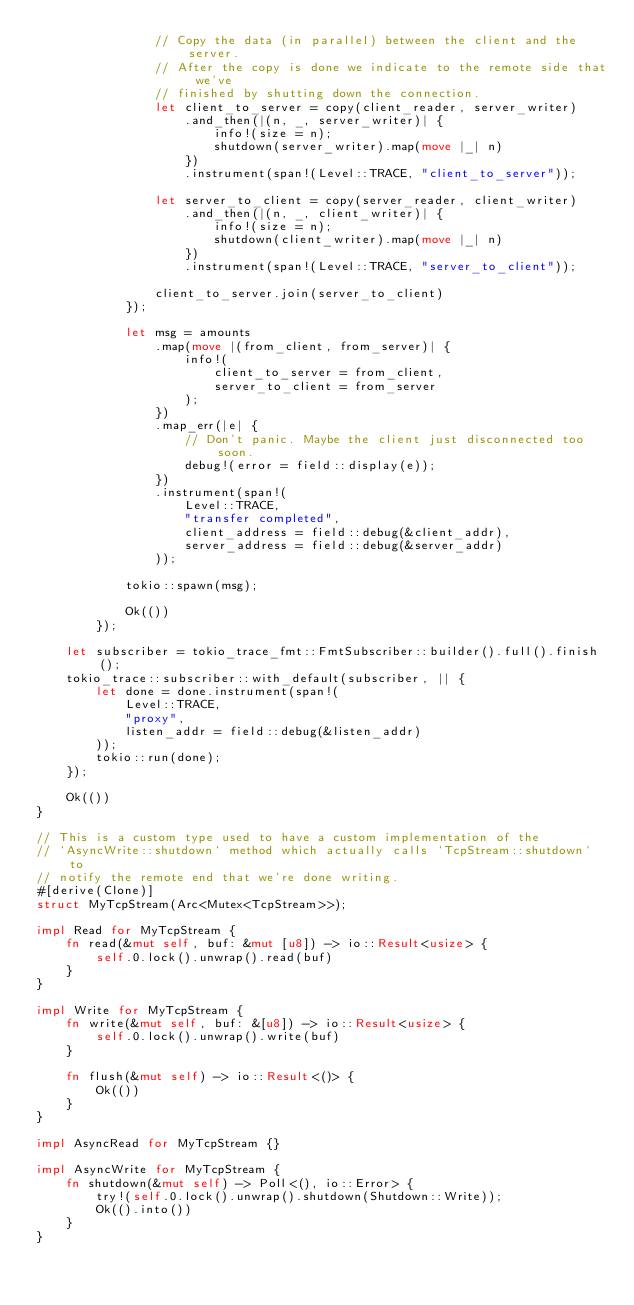Convert code to text. <code><loc_0><loc_0><loc_500><loc_500><_Rust_>                // Copy the data (in parallel) between the client and the server.
                // After the copy is done we indicate to the remote side that we've
                // finished by shutting down the connection.
                let client_to_server = copy(client_reader, server_writer)
                    .and_then(|(n, _, server_writer)| {
                        info!(size = n);
                        shutdown(server_writer).map(move |_| n)
                    })
                    .instrument(span!(Level::TRACE, "client_to_server"));

                let server_to_client = copy(server_reader, client_writer)
                    .and_then(|(n, _, client_writer)| {
                        info!(size = n);
                        shutdown(client_writer).map(move |_| n)
                    })
                    .instrument(span!(Level::TRACE, "server_to_client"));

                client_to_server.join(server_to_client)
            });

            let msg = amounts
                .map(move |(from_client, from_server)| {
                    info!(
                        client_to_server = from_client,
                        server_to_client = from_server
                    );
                })
                .map_err(|e| {
                    // Don't panic. Maybe the client just disconnected too soon.
                    debug!(error = field::display(e));
                })
                .instrument(span!(
                    Level::TRACE,
                    "transfer completed",
                    client_address = field::debug(&client_addr),
                    server_address = field::debug(&server_addr)
                ));

            tokio::spawn(msg);

            Ok(())
        });

    let subscriber = tokio_trace_fmt::FmtSubscriber::builder().full().finish();
    tokio_trace::subscriber::with_default(subscriber, || {
        let done = done.instrument(span!(
            Level::TRACE,
            "proxy",
            listen_addr = field::debug(&listen_addr)
        ));
        tokio::run(done);
    });

    Ok(())
}

// This is a custom type used to have a custom implementation of the
// `AsyncWrite::shutdown` method which actually calls `TcpStream::shutdown` to
// notify the remote end that we're done writing.
#[derive(Clone)]
struct MyTcpStream(Arc<Mutex<TcpStream>>);

impl Read for MyTcpStream {
    fn read(&mut self, buf: &mut [u8]) -> io::Result<usize> {
        self.0.lock().unwrap().read(buf)
    }
}

impl Write for MyTcpStream {
    fn write(&mut self, buf: &[u8]) -> io::Result<usize> {
        self.0.lock().unwrap().write(buf)
    }

    fn flush(&mut self) -> io::Result<()> {
        Ok(())
    }
}

impl AsyncRead for MyTcpStream {}

impl AsyncWrite for MyTcpStream {
    fn shutdown(&mut self) -> Poll<(), io::Error> {
        try!(self.0.lock().unwrap().shutdown(Shutdown::Write));
        Ok(().into())
    }
}
</code> 